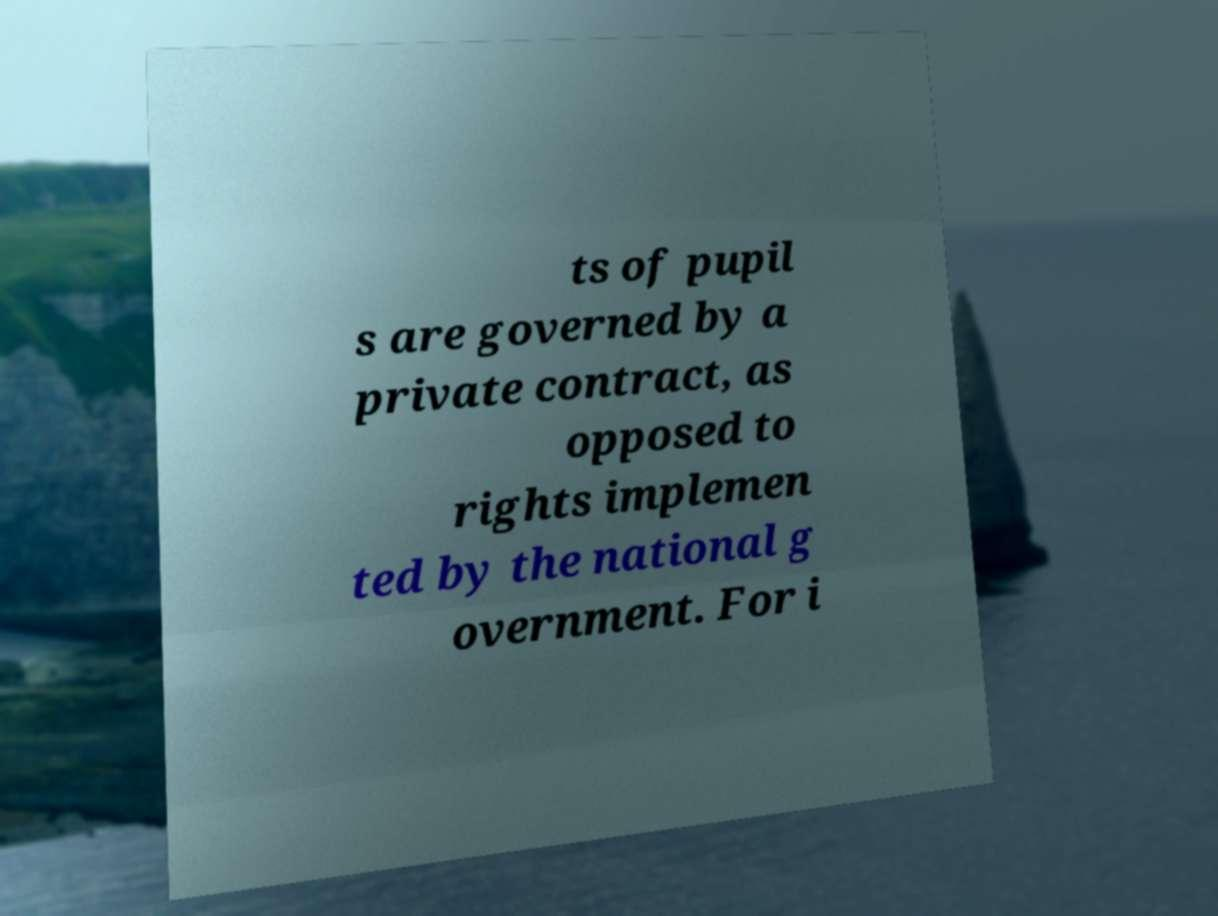Can you read and provide the text displayed in the image?This photo seems to have some interesting text. Can you extract and type it out for me? ts of pupil s are governed by a private contract, as opposed to rights implemen ted by the national g overnment. For i 